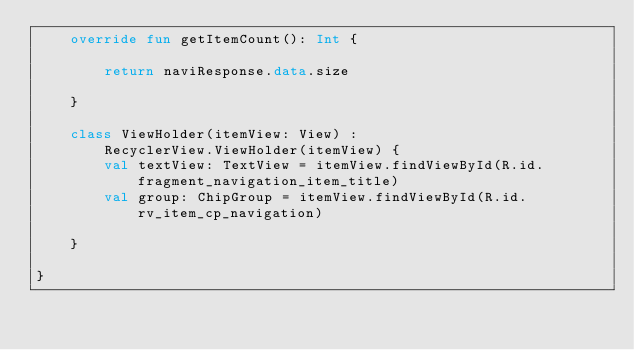<code> <loc_0><loc_0><loc_500><loc_500><_Kotlin_>    override fun getItemCount(): Int {

        return naviResponse.data.size

    }

    class ViewHolder(itemView: View) :
        RecyclerView.ViewHolder(itemView) {
        val textView: TextView = itemView.findViewById(R.id.fragment_navigation_item_title)
        val group: ChipGroup = itemView.findViewById(R.id.rv_item_cp_navigation)

    }

}</code> 